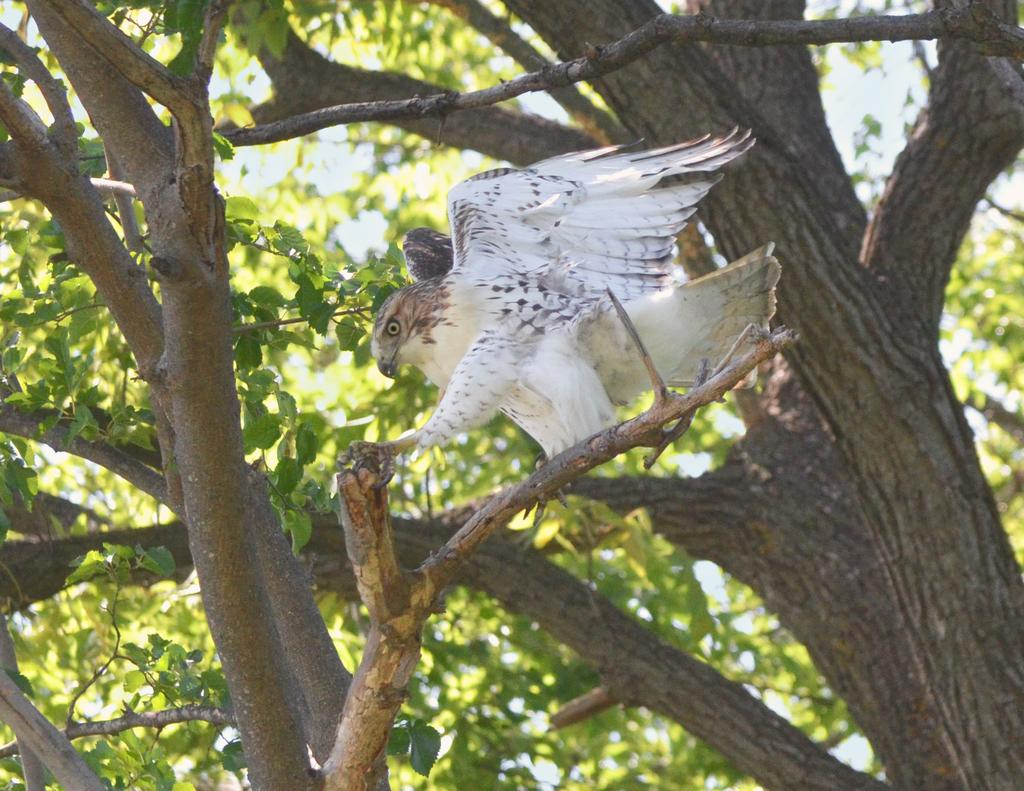What type of vegetation is present in the image? The image contains trees. What animal can be seen in the image? There is an eagle in the center of the image. How many thumbs can be seen on the eagle in the image? There are no thumbs visible in the image, as eagles do not have thumbs. What level of experience does the beginner eagle have in the image? There is no indication of the eagle's experience level in the image, as it is a single eagle and not a group of eagles with varying levels of experience. 